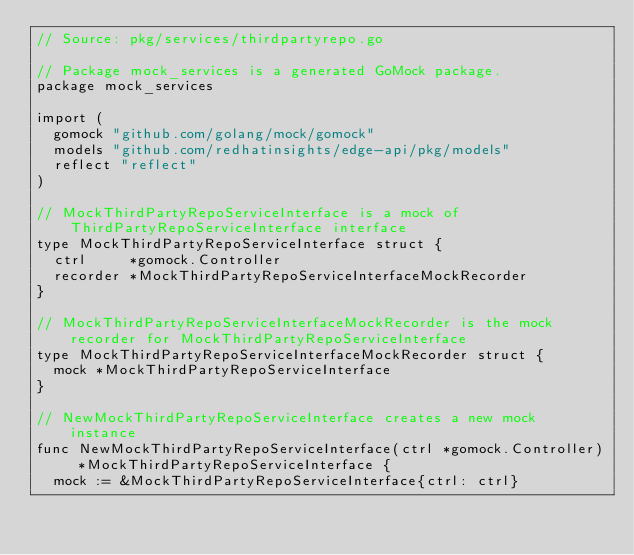Convert code to text. <code><loc_0><loc_0><loc_500><loc_500><_Go_>// Source: pkg/services/thirdpartyrepo.go

// Package mock_services is a generated GoMock package.
package mock_services

import (
	gomock "github.com/golang/mock/gomock"
	models "github.com/redhatinsights/edge-api/pkg/models"
	reflect "reflect"
)

// MockThirdPartyRepoServiceInterface is a mock of ThirdPartyRepoServiceInterface interface
type MockThirdPartyRepoServiceInterface struct {
	ctrl     *gomock.Controller
	recorder *MockThirdPartyRepoServiceInterfaceMockRecorder
}

// MockThirdPartyRepoServiceInterfaceMockRecorder is the mock recorder for MockThirdPartyRepoServiceInterface
type MockThirdPartyRepoServiceInterfaceMockRecorder struct {
	mock *MockThirdPartyRepoServiceInterface
}

// NewMockThirdPartyRepoServiceInterface creates a new mock instance
func NewMockThirdPartyRepoServiceInterface(ctrl *gomock.Controller) *MockThirdPartyRepoServiceInterface {
	mock := &MockThirdPartyRepoServiceInterface{ctrl: ctrl}</code> 